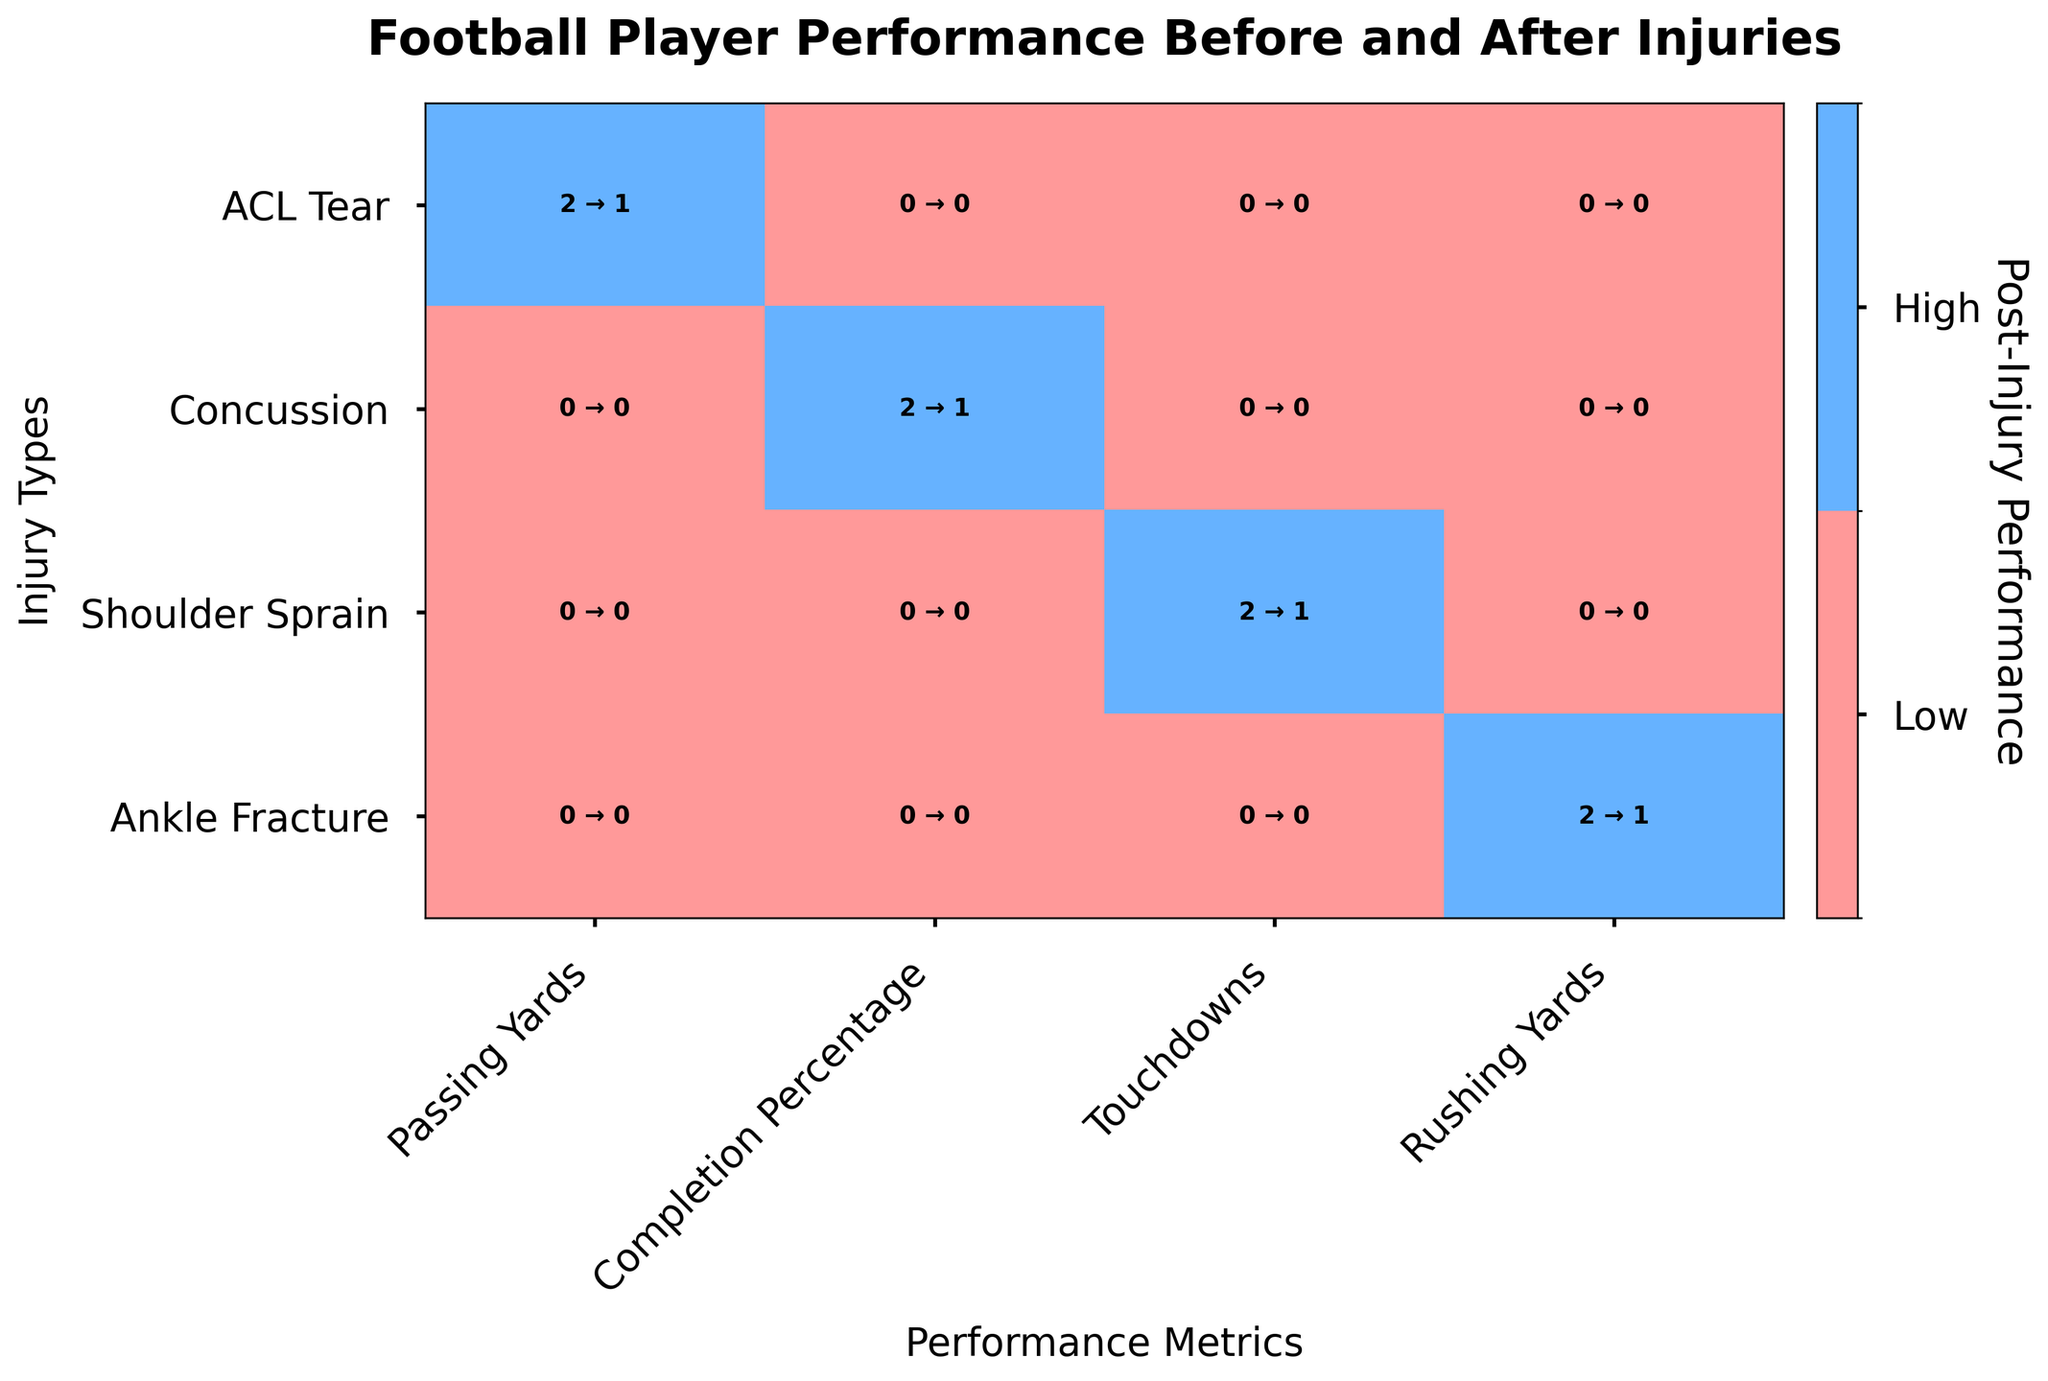What type of injury shows the most significant drop in performance for Passing Yards? Look at the cells in the Passing Yards column and compare pre-injury and post-injury values for ACL Tear, Concussion, and Shoulder Sprain. ACL Tear shows a significant drop.
Answer: ACL Tear How many Concussion injuries resulted in a high Completion Percentage post-injury? Check the cell for Concussion and Completion Percentage, and read the post-injury value. It shows the number 1.
Answer: 1 Which performance metric retained the most "High" levels post-injury for ankle fractures? Check each performance metric row for Ankle Fracture and identify which one has the highest count of "High" post-injury. Rushing Yards shows 0 to 1.
Answer: Rushing Yards What is the overall trend for Shoulder Sprain regarding Touchdowns pre- and post-injury? Look at the Shoulder Sprain row in the Touchdowns column and compare the pre-injury (1 High) and post-injury (most of them Low). The trend shows a decrease in performance.
Answer: Decrease Which injury type had no change in high-level Completion Percentage post-injury? Look for the cells where pre-injury and post-injury values are the same. Concussion's high Completion Percentage went from 1 to 1.
Answer: Concussion Which performance metric shows the greatest decline post-injury for ACL tears? Check the row corresponding to ACL Tears across different performance metrics and compare pre- and post-injury values. Passing Yards went from 1 High pre-injury to 1 Low post-injury, showing a significant decline.
Answer: Passing Yards How many pre-injury high performances were retained post-injury across all types? Sum up all cases in all rows and columns where the pre-injury and post-injury values are both "High." Sum for ACL Tear, Concussion, Shoulder Sprain, and Ankle Fracture injuries across their respective performance metrics.
Answer: 3 